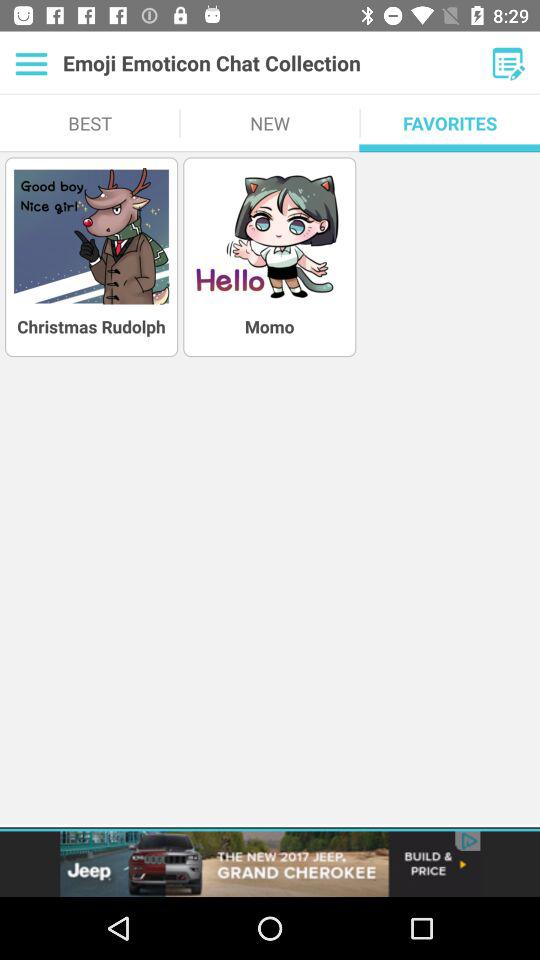Which is the selected tab? The selected tab is "FAVORITES". 